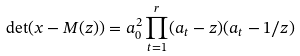Convert formula to latex. <formula><loc_0><loc_0><loc_500><loc_500>\det ( x - M ( z ) ) = a _ { 0 } ^ { 2 } \prod _ { t = 1 } ^ { r } ( a _ { t } - z ) ( a _ { t } - 1 / z )</formula> 